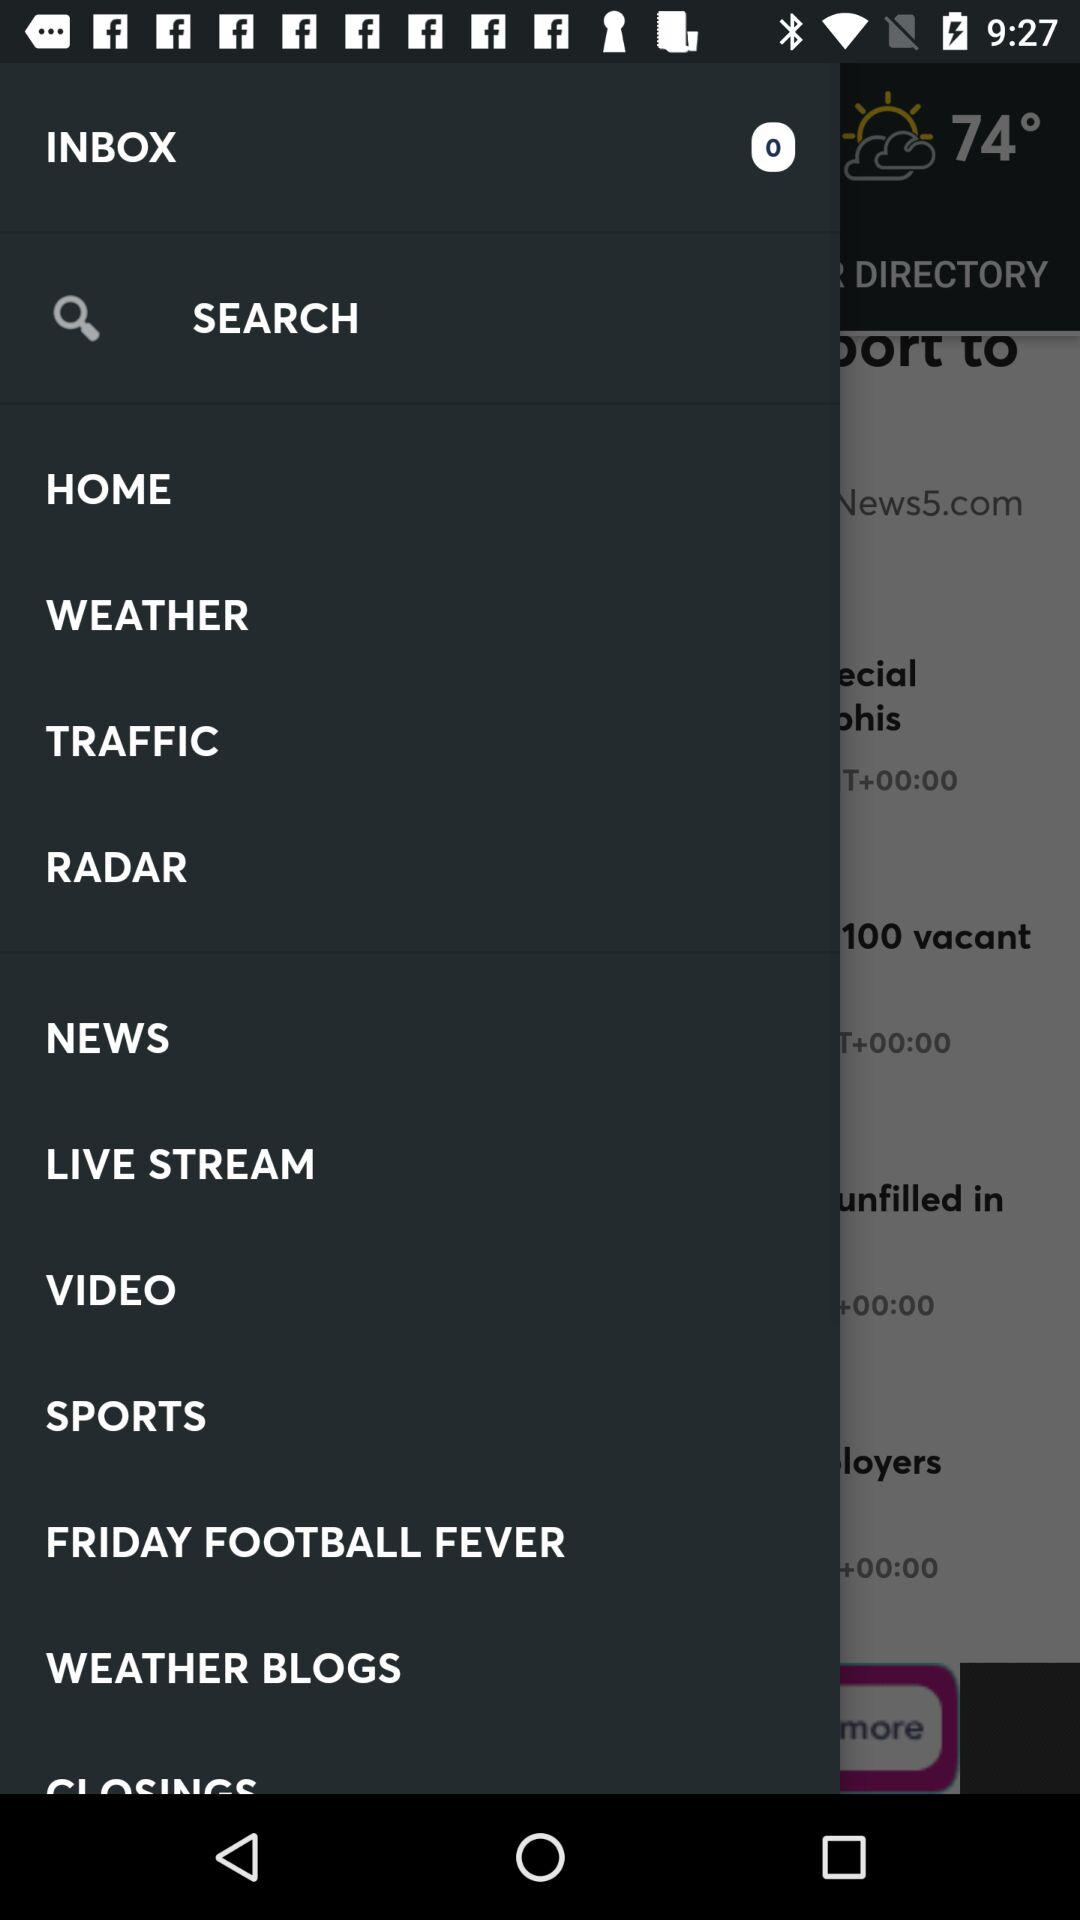How many notifications are there in "INBOX"? There are 0 notifications. 